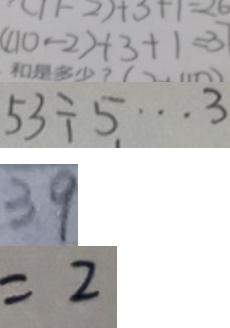<formula> <loc_0><loc_0><loc_500><loc_500>( 1 1 0 - 2 ) + 3 + 1 = 3 7 
 5 3 \div 5 \cdots 3 
 3 9 
 = 2</formula> 